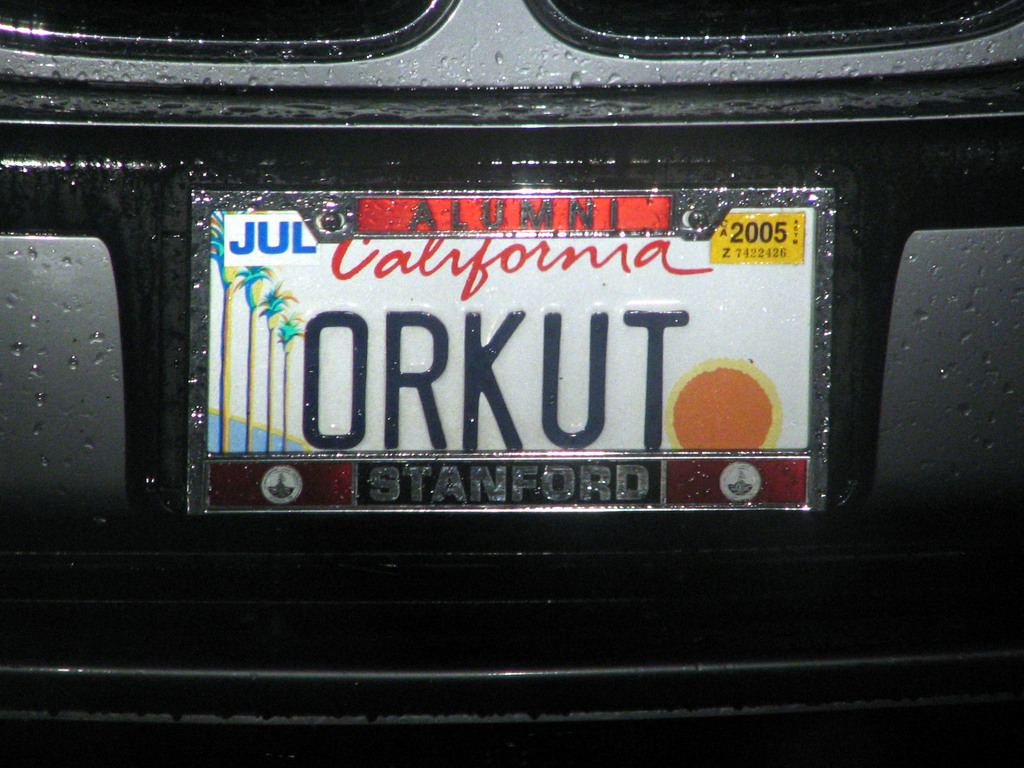Write a detailed description of the given image. The image depicts a close-up view of a black car's rear license plate, which is wet, indicating recent rain exposure. The plate features a custom name 'Orkut', set against a vibrant motif depicting a red setting sun and palm trees, quintessential Californian imagery. Notably, the plate includes a 'Stanford Alumni' sticker which suggests that the car's owner may be an alumnus of Stanford University. The sticker top-right corner of the plate shows that the registration expired in July 2005, providing a temporal anchor showing the photo was taken at or before this date. This personalized plate, combined with the alumni sticker, portrays personal and educational pride, while the wet surface and Californian background hint at both timing and location specifics. 